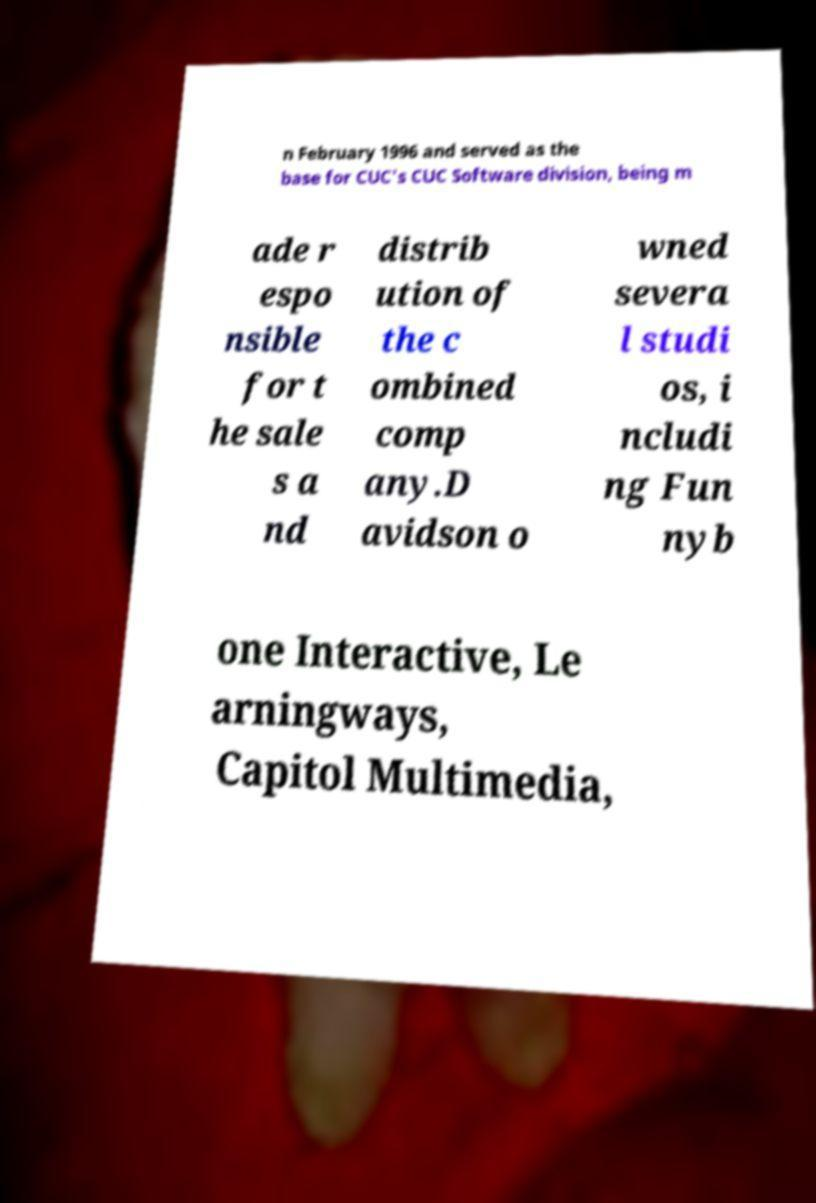What messages or text are displayed in this image? I need them in a readable, typed format. n February 1996 and served as the base for CUC's CUC Software division, being m ade r espo nsible for t he sale s a nd distrib ution of the c ombined comp any.D avidson o wned severa l studi os, i ncludi ng Fun nyb one Interactive, Le arningways, Capitol Multimedia, 